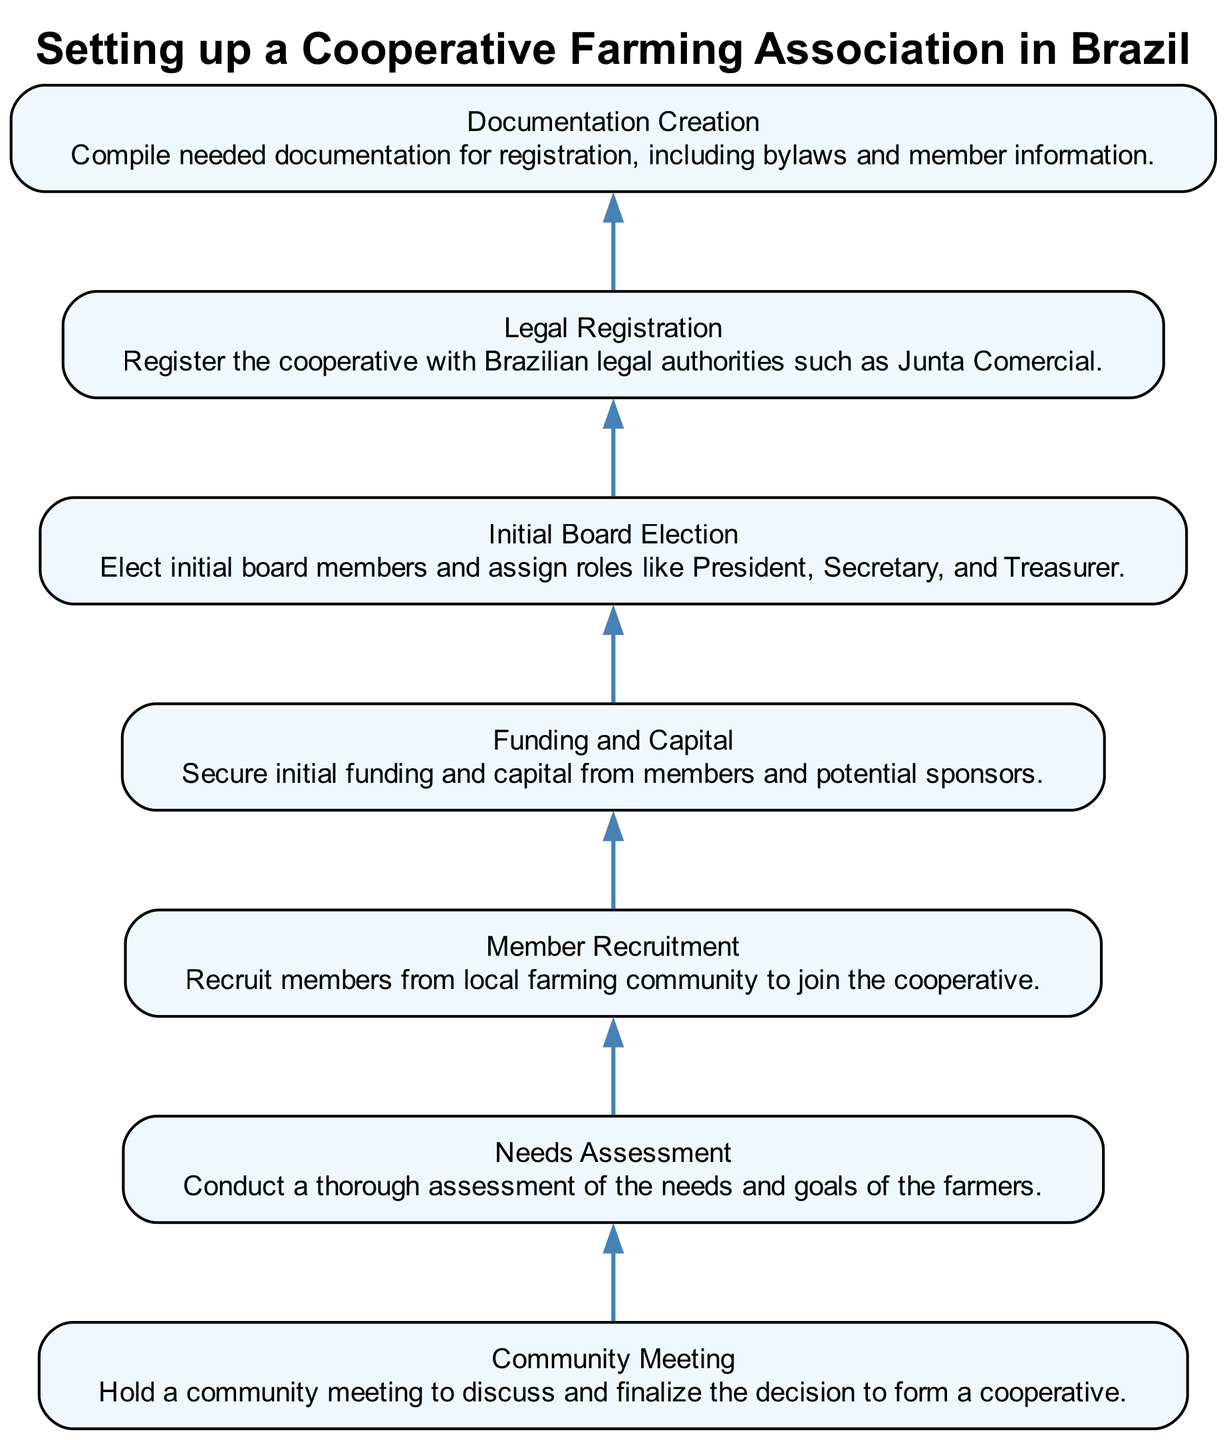What is the first step in the diagram? The diagram presents the steps in reverse order, with the first step being at the bottom. Therefore, I check the bottom node, which shows "Needs Assessment".
Answer: Needs Assessment How many nodes are there in total? The diagram includes a step described for each node. Counting them reveals there are 7 distinct steps representing nodes.
Answer: 7 What is the last step before legal registration? To find this, I identify the step that immediately precedes "Legal Registration" in the upward flow of the diagram, which is "Initial Board Election".
Answer: Initial Board Election What is the main purpose of the community meeting step? The description attached to the "Community Meeting" node reveals it is focused on discussing and finalizing the decision about forming the cooperative.
Answer: Discussing and finalizing Which step focuses on acquiring financial resources? By analyzing the descriptions of the nodes, "Funding and Capital" is specifically talking about securing initial funding and capital, detailing the financial aspect.
Answer: Funding and Capital In which step are bylaws compiled? The "Documentation Creation" step explicitly states the need to compile necessary documents, including bylaws for registration.
Answer: Documentation Creation What step follows member recruitment? By tracing the upward connections in the diagram, the step that directly follows "Member Recruitment" is "Funding and Capital".
Answer: Funding and Capital 